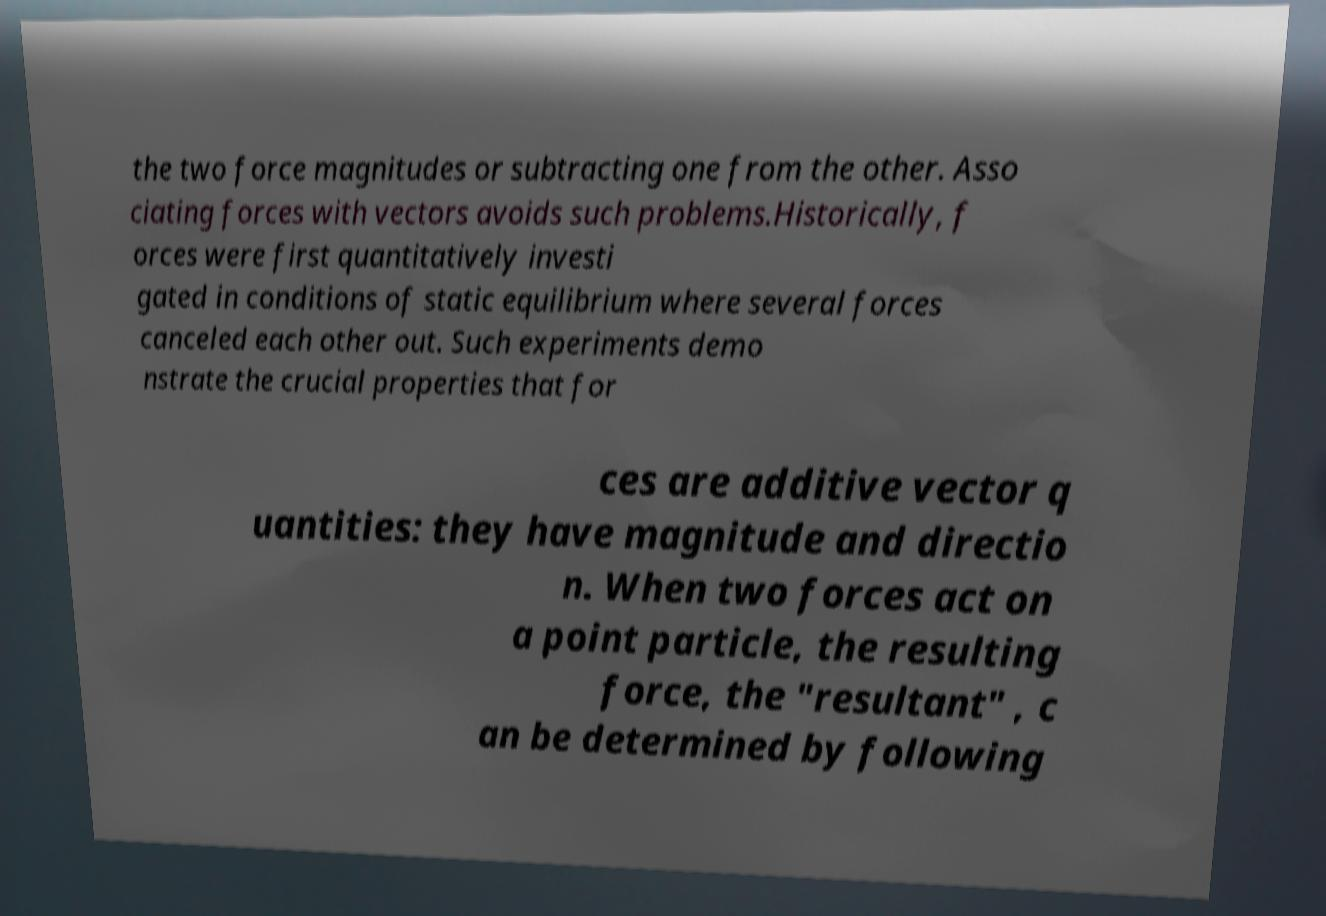There's text embedded in this image that I need extracted. Can you transcribe it verbatim? the two force magnitudes or subtracting one from the other. Asso ciating forces with vectors avoids such problems.Historically, f orces were first quantitatively investi gated in conditions of static equilibrium where several forces canceled each other out. Such experiments demo nstrate the crucial properties that for ces are additive vector q uantities: they have magnitude and directio n. When two forces act on a point particle, the resulting force, the "resultant" , c an be determined by following 